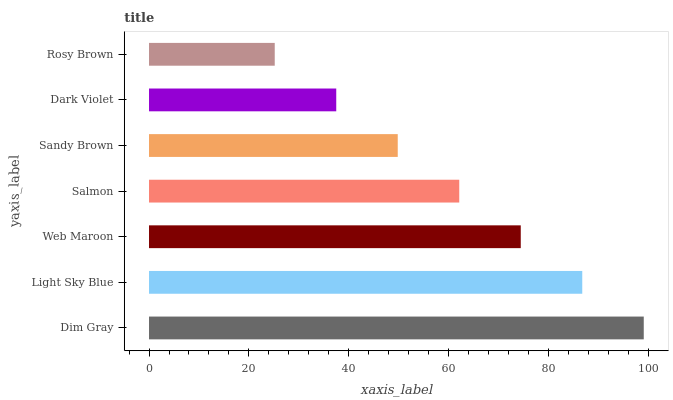Is Rosy Brown the minimum?
Answer yes or no. Yes. Is Dim Gray the maximum?
Answer yes or no. Yes. Is Light Sky Blue the minimum?
Answer yes or no. No. Is Light Sky Blue the maximum?
Answer yes or no. No. Is Dim Gray greater than Light Sky Blue?
Answer yes or no. Yes. Is Light Sky Blue less than Dim Gray?
Answer yes or no. Yes. Is Light Sky Blue greater than Dim Gray?
Answer yes or no. No. Is Dim Gray less than Light Sky Blue?
Answer yes or no. No. Is Salmon the high median?
Answer yes or no. Yes. Is Salmon the low median?
Answer yes or no. Yes. Is Dim Gray the high median?
Answer yes or no. No. Is Light Sky Blue the low median?
Answer yes or no. No. 